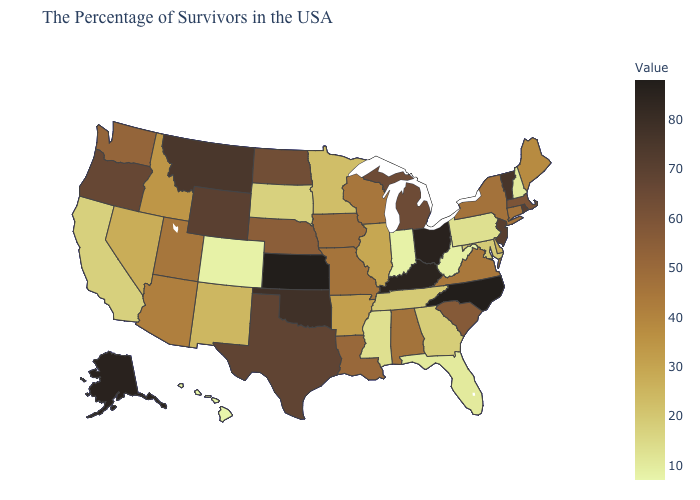Does the map have missing data?
Quick response, please. No. Which states hav the highest value in the MidWest?
Keep it brief. Kansas. Among the states that border Minnesota , which have the highest value?
Write a very short answer. North Dakota. 